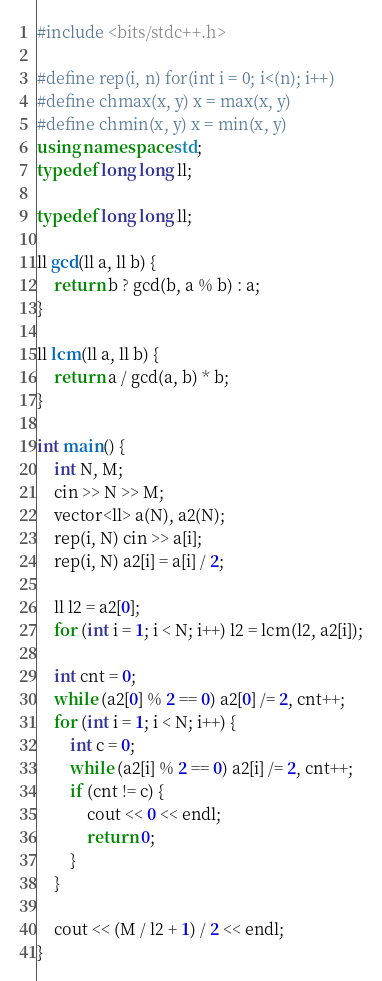<code> <loc_0><loc_0><loc_500><loc_500><_C++_>#include <bits/stdc++.h>

#define rep(i, n) for(int i = 0; i<(n); i++)
#define chmax(x, y) x = max(x, y)
#define chmin(x, y) x = min(x, y)
using namespace std;
typedef long long ll;

typedef long long ll;

ll gcd(ll a, ll b) {
    return b ? gcd(b, a % b) : a;
}

ll lcm(ll a, ll b) {
    return a / gcd(a, b) * b;
}

int main() {
    int N, M;
    cin >> N >> M;
    vector<ll> a(N), a2(N);
    rep(i, N) cin >> a[i];
    rep(i, N) a2[i] = a[i] / 2;

    ll l2 = a2[0];
    for (int i = 1; i < N; i++) l2 = lcm(l2, a2[i]);

    int cnt = 0;
    while (a2[0] % 2 == 0) a2[0] /= 2, cnt++;
    for (int i = 1; i < N; i++) {
        int c = 0;
        while (a2[i] % 2 == 0) a2[i] /= 2, cnt++;
        if (cnt != c) {
            cout << 0 << endl;
            return 0;
        }
    }

    cout << (M / l2 + 1) / 2 << endl;
}</code> 